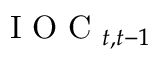<formula> <loc_0><loc_0><loc_500><loc_500>I O C _ { t , t - 1 }</formula> 